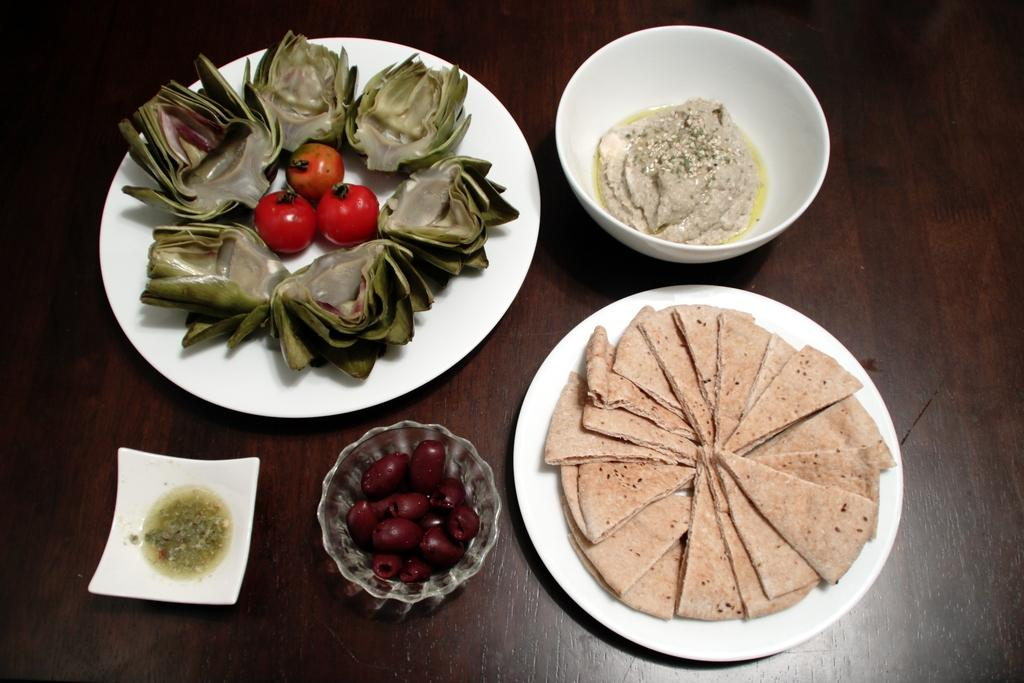What types of dishes are present in the image? There are plates and bowls in the image. What type of food can be seen in the image? There are tomatoes in the image. Where is the food placed in the image? The food is placed on a wooden platform in the image. How many women are participating in the competition shown in the image? There are no women or competition present in the image. 